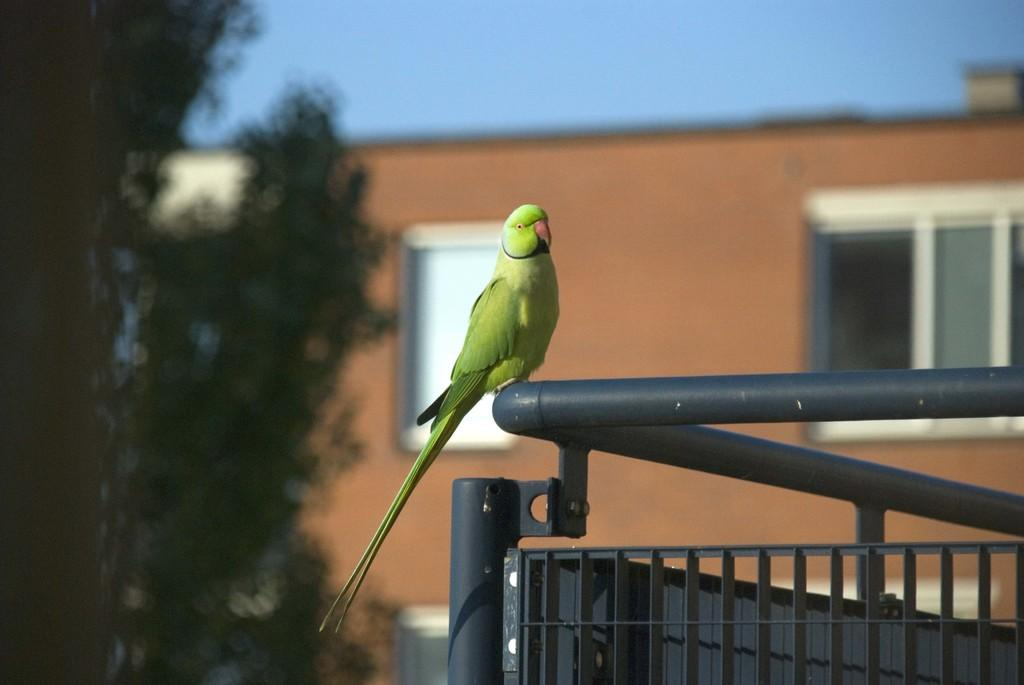What animal is on the railing in the image? There is a parrot on a railing in the image. What type of vegetation is on the left side of the image? There are trees on the left side of the image. What can be seen in the background of the image? There is a building and the sky visible in the background of the image. Is there any quicksand visible in the image? No, there is no quicksand present in the image. Where is the seat located in the image? There is no seat mentioned or visible in the image. 